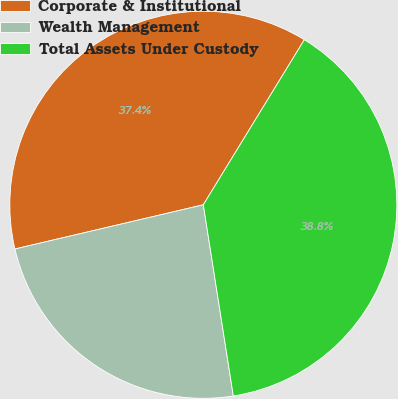Convert chart to OTSL. <chart><loc_0><loc_0><loc_500><loc_500><pie_chart><fcel>Corporate & Institutional<fcel>Wealth Management<fcel>Total Assets Under Custody<nl><fcel>37.41%<fcel>23.81%<fcel>38.78%<nl></chart> 